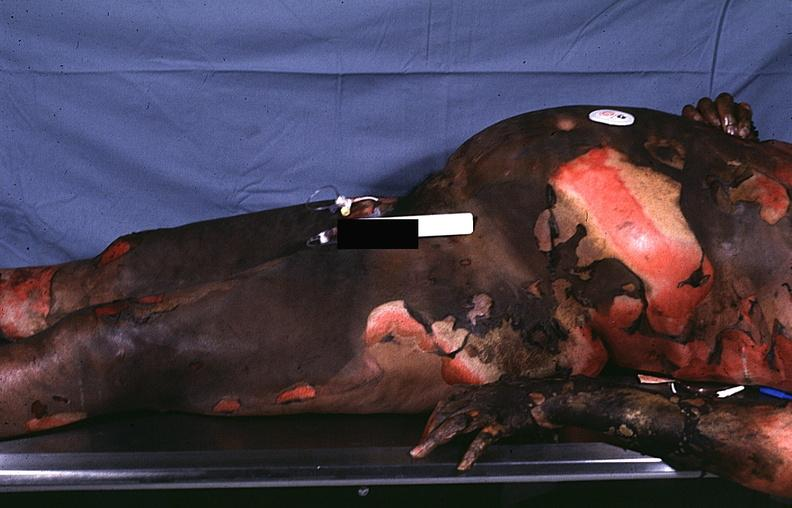do thermal burn?
Answer the question using a single word or phrase. Yes 